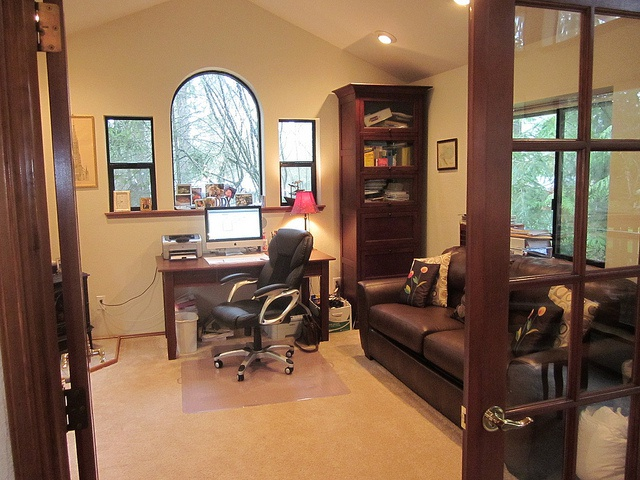Describe the objects in this image and their specific colors. I can see couch in maroon, black, and brown tones, chair in maroon, black, and gray tones, tv in maroon, white, gray, lightblue, and darkgray tones, book in maroon, gray, tan, and brown tones, and book in maroon, olive, and black tones in this image. 